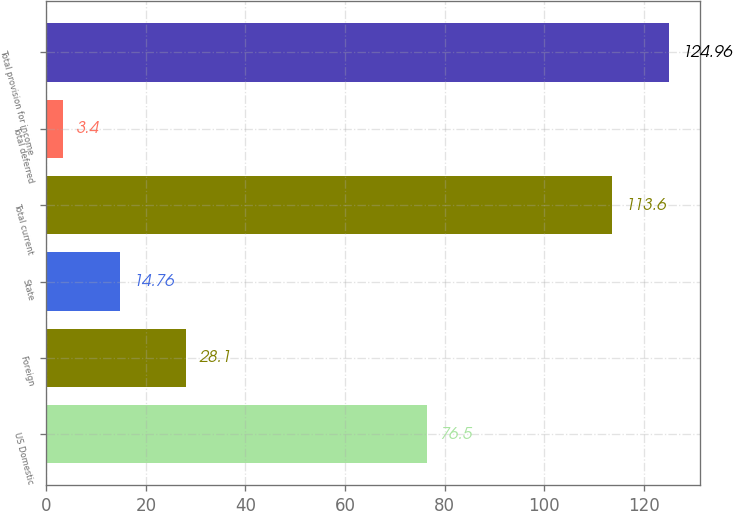Convert chart to OTSL. <chart><loc_0><loc_0><loc_500><loc_500><bar_chart><fcel>US Domestic<fcel>Foreign<fcel>State<fcel>Total current<fcel>Total deferred<fcel>Total provision for income<nl><fcel>76.5<fcel>28.1<fcel>14.76<fcel>113.6<fcel>3.4<fcel>124.96<nl></chart> 